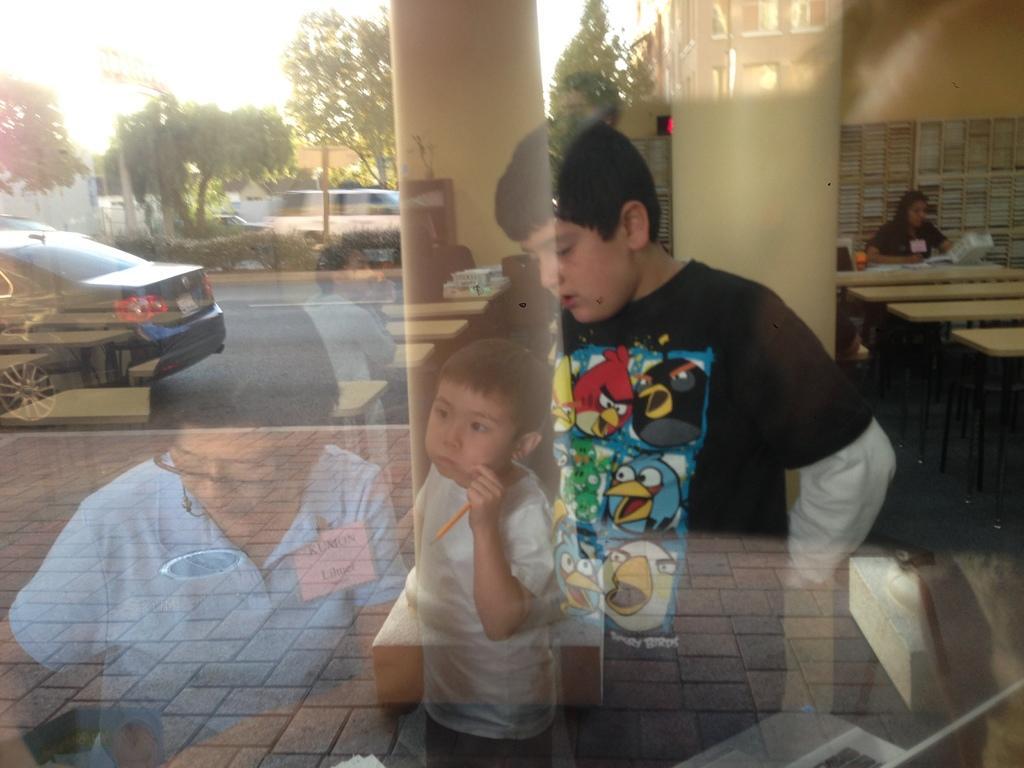Please provide a concise description of this image. In this image we can see there is a reflection of people on the glass, behind them there are buildings, trees and car on the road. 